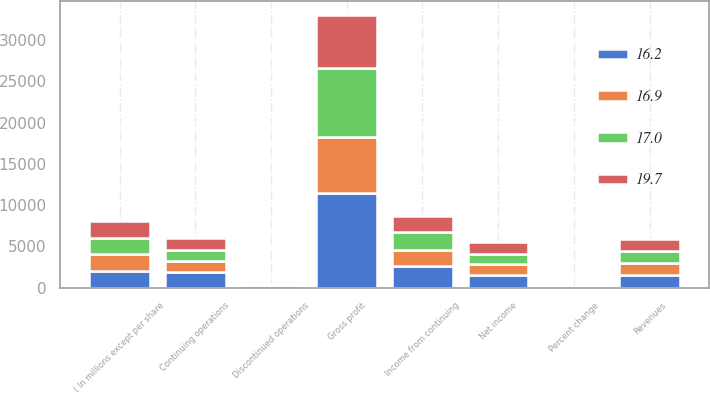Convert chart. <chart><loc_0><loc_0><loc_500><loc_500><stacked_bar_chart><ecel><fcel>( In millions except per share<fcel>Revenues<fcel>Percent change<fcel>Gross profit<fcel>Income from continuing<fcel>Continuing operations<fcel>Discontinued operations<fcel>Net income<nl><fcel>16.2<fcel>2015<fcel>1478.5<fcel>30.3<fcel>11411<fcel>2657<fcel>1842<fcel>299<fcel>1543<nl><fcel>17<fcel>2014<fcel>1478.5<fcel>12.4<fcel>8352<fcel>2171<fcel>1414<fcel>156<fcel>1258<nl><fcel>16.9<fcel>2013<fcel>1478.5<fcel>0.2<fcel>6881<fcel>1950<fcel>1363<fcel>25<fcel>1338<nl><fcel>19.7<fcel>2012<fcel>1478.5<fcel>9.5<fcel>6435<fcel>1915<fcel>1394<fcel>9<fcel>1403<nl></chart> 